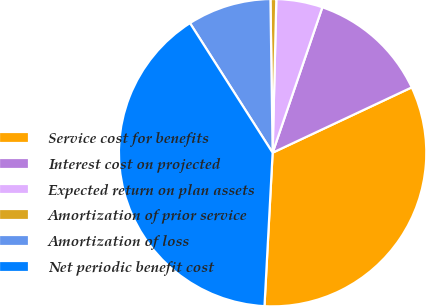<chart> <loc_0><loc_0><loc_500><loc_500><pie_chart><fcel>Service cost for benefits<fcel>Interest cost on projected<fcel>Expected return on plan assets<fcel>Amortization of prior service<fcel>Amortization of loss<fcel>Net periodic benefit cost<nl><fcel>32.83%<fcel>12.77%<fcel>4.86%<fcel>0.61%<fcel>8.81%<fcel>40.12%<nl></chart> 